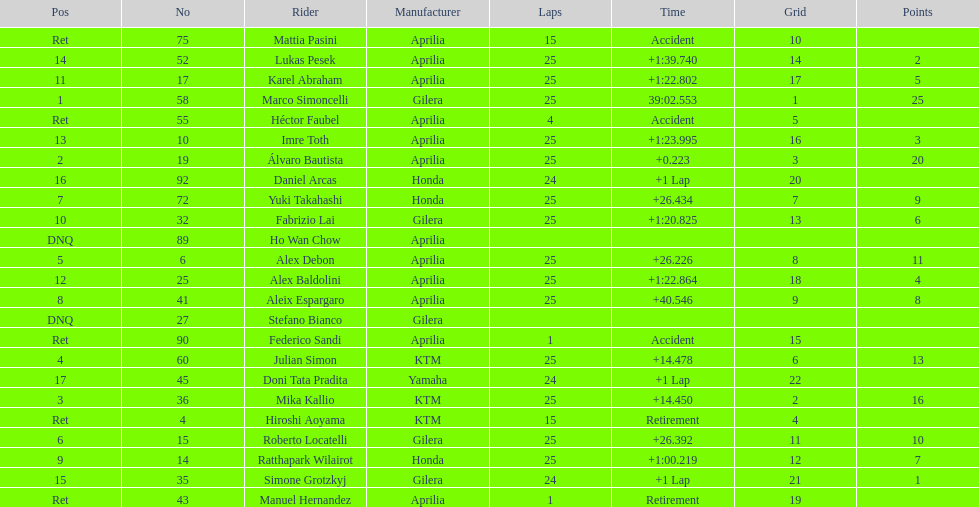What is the total number of rider? 24. 